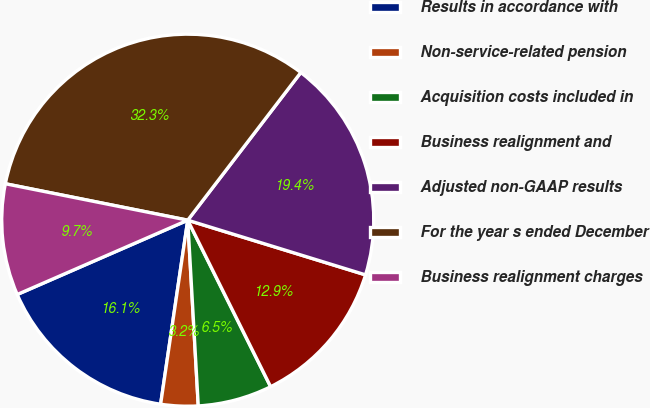<chart> <loc_0><loc_0><loc_500><loc_500><pie_chart><fcel>Results in accordance with<fcel>Non-service-related pension<fcel>Acquisition costs included in<fcel>Business realignment and<fcel>Adjusted non-GAAP results<fcel>For the year s ended December<fcel>Business realignment charges<nl><fcel>16.13%<fcel>3.23%<fcel>6.45%<fcel>12.9%<fcel>19.35%<fcel>32.26%<fcel>9.68%<nl></chart> 